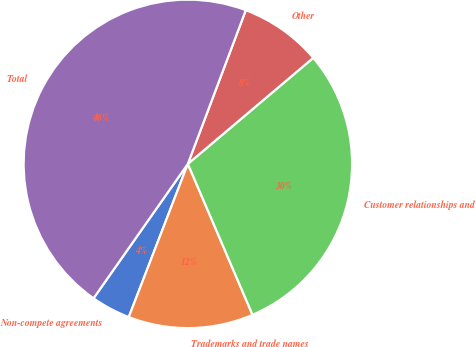Convert chart to OTSL. <chart><loc_0><loc_0><loc_500><loc_500><pie_chart><fcel>Non-compete agreements<fcel>Trademarks and trade names<fcel>Customer relationships and<fcel>Other<fcel>Total<nl><fcel>3.88%<fcel>12.3%<fcel>29.73%<fcel>8.09%<fcel>46.0%<nl></chart> 